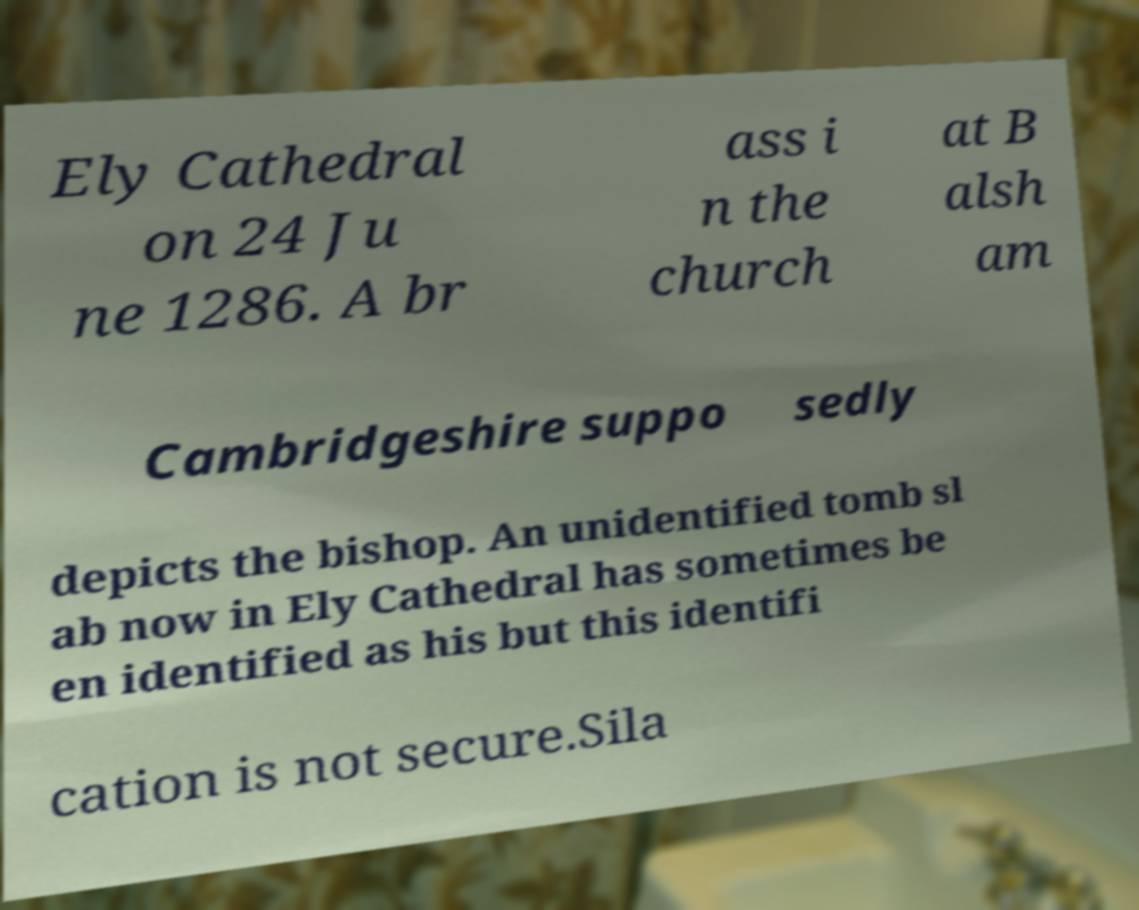Can you accurately transcribe the text from the provided image for me? Ely Cathedral on 24 Ju ne 1286. A br ass i n the church at B alsh am Cambridgeshire suppo sedly depicts the bishop. An unidentified tomb sl ab now in Ely Cathedral has sometimes be en identified as his but this identifi cation is not secure.Sila 